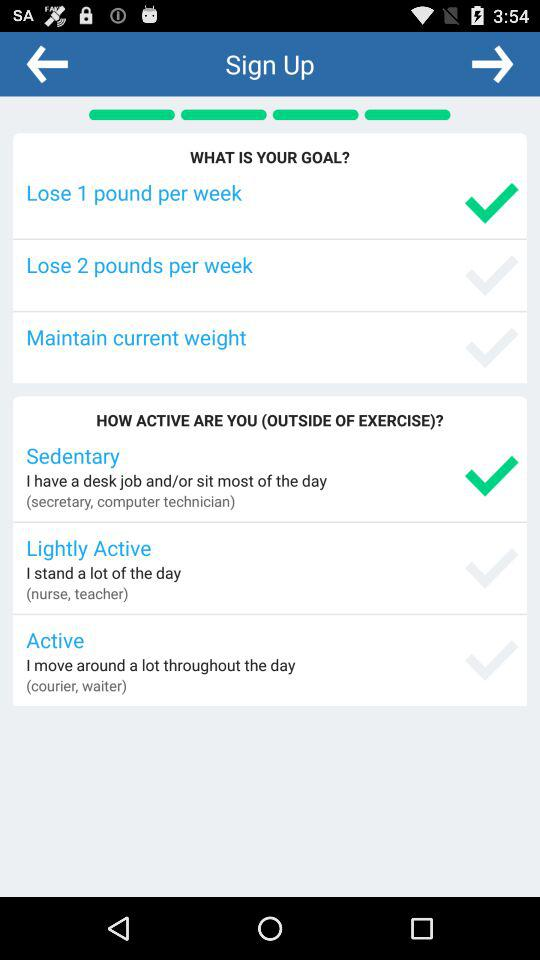Which option is selected in "WHAT IS YOUR GOAL"? The selected option is "Lose 1 pound per week". 